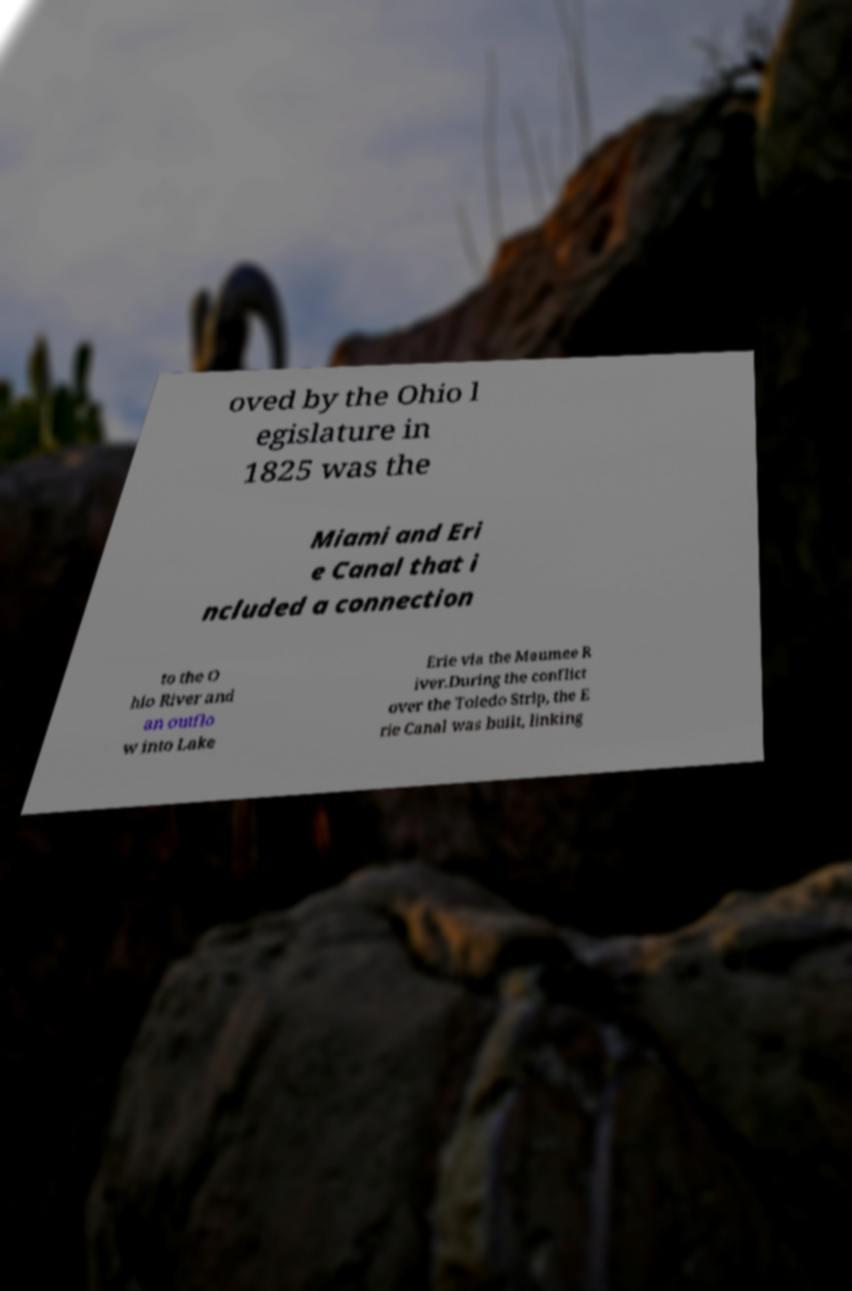What messages or text are displayed in this image? I need them in a readable, typed format. oved by the Ohio l egislature in 1825 was the Miami and Eri e Canal that i ncluded a connection to the O hio River and an outflo w into Lake Erie via the Maumee R iver.During the conflict over the Toledo Strip, the E rie Canal was built, linking 